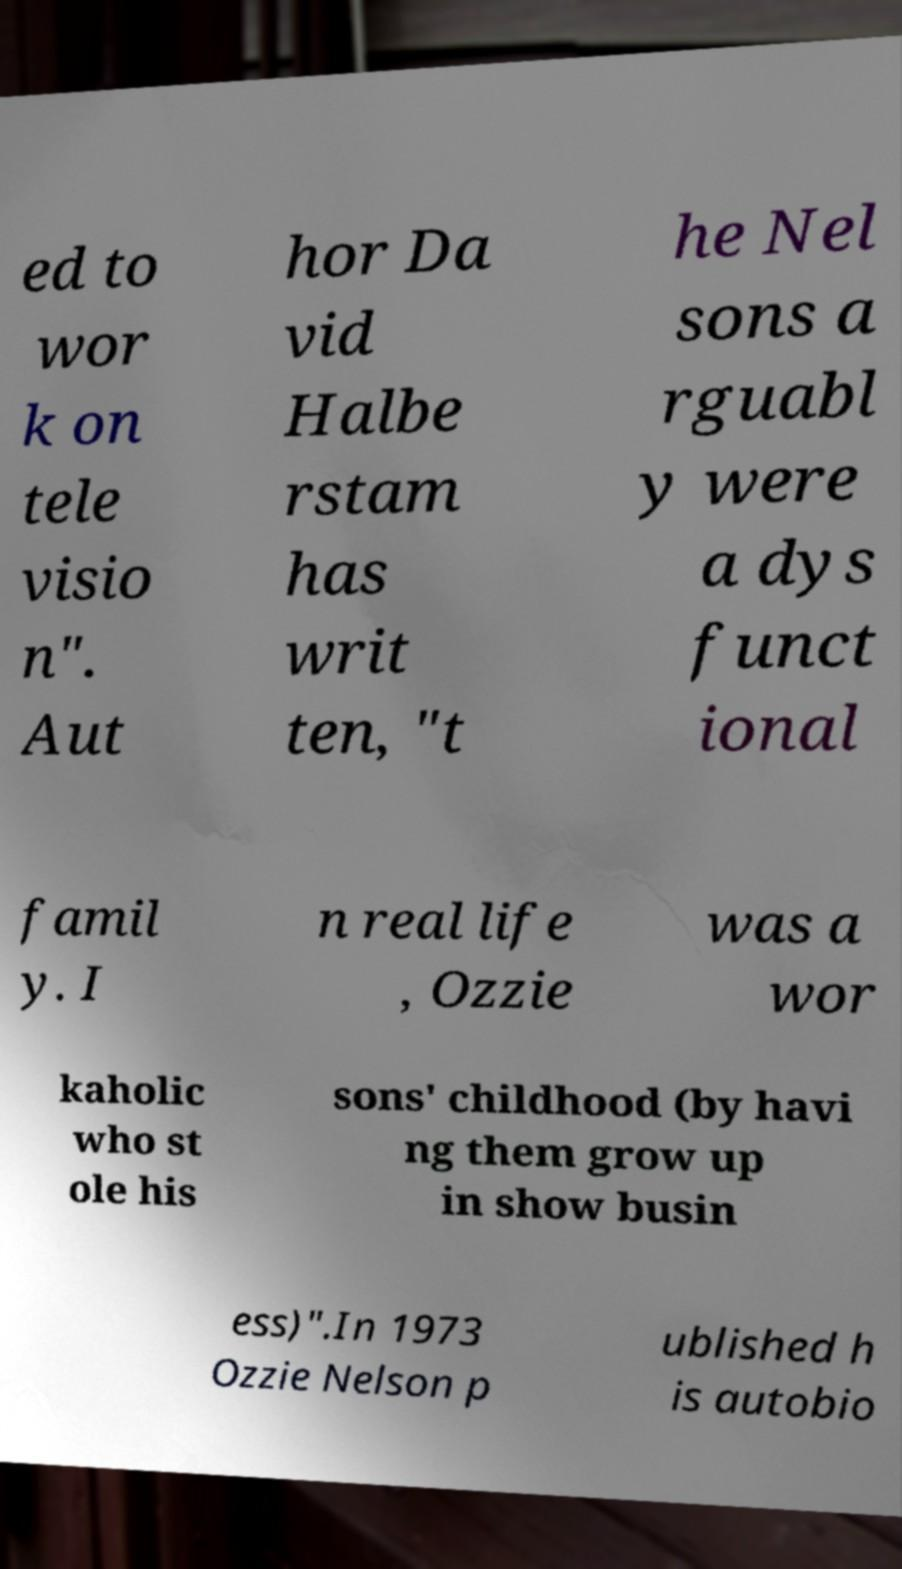For documentation purposes, I need the text within this image transcribed. Could you provide that? ed to wor k on tele visio n". Aut hor Da vid Halbe rstam has writ ten, "t he Nel sons a rguabl y were a dys funct ional famil y. I n real life , Ozzie was a wor kaholic who st ole his sons' childhood (by havi ng them grow up in show busin ess)".In 1973 Ozzie Nelson p ublished h is autobio 